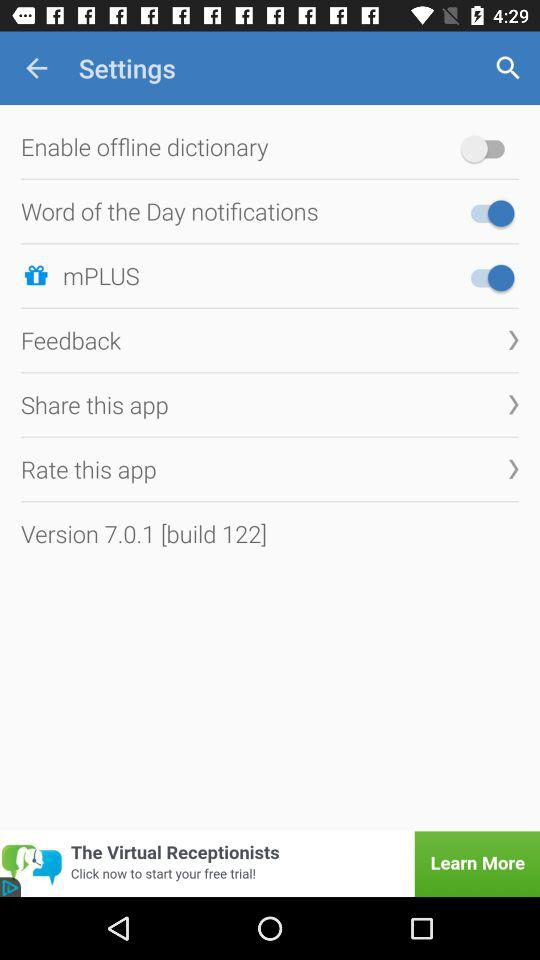What is the status of the "Word of the Day notifications" button? The status of the "Word of the Day notifications" button is "on". 